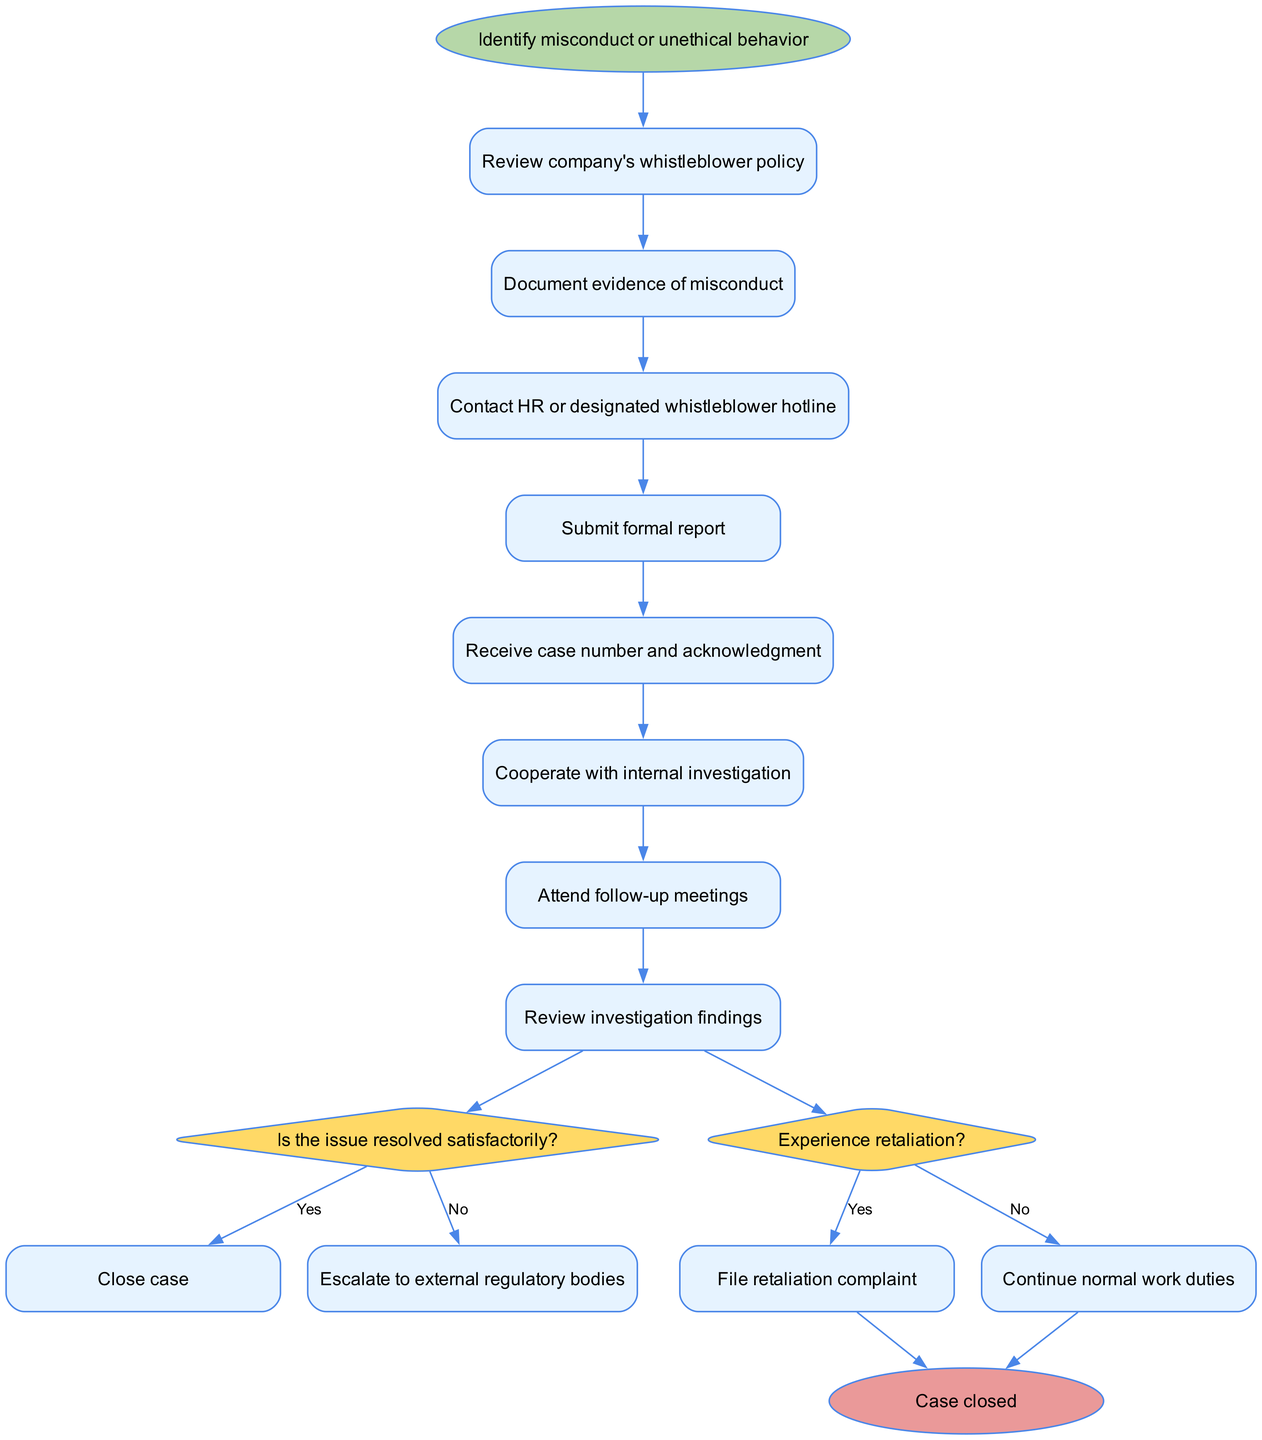What is the starting point of the process? The starting point of the process is indicated as "Identify misconduct or unethical behavior" in the diagram. This is the first node from which all activities flow.
Answer: Identify misconduct or unethical behavior How many activities are in the diagram? By counting the nodes labeled as activities, we find there are eight distinct activities listed before reaching the decision nodes.
Answer: 8 What is the first activity to complete after identifying misconduct? The first activity after the starting point is "Review company's whistleblower policy," which follows directly from the initial identification stage.
Answer: Review company's whistleblower policy What happens if the issue is resolved satisfactorily? If the issue is resolved satisfactorily, the flow indicates we proceed to "Close case," which is the next step following the decision node for satisfactory resolution.
Answer: Close case What is the next step after submitting a formal report? After submitting a formal report, the next step indicated is receiving a case number and acknowledgment, creating a clear flow of activities leading from one to another.
Answer: Receive case number and acknowledgment What are the two potential outcomes after reviewing the investigation findings? The two potential outcomes are labeled under the decision points, which are "Close case" if resolved satisfactorily and "Escalate to external regulatory bodies" if not resolved satisfactorily.
Answer: Close case or Escalate to external regulatory bodies What must you do if you experience retaliation? If retaliation is experienced, the diagram indicates the next action is to "File retaliation complaint," showing a clear response to such an instance.
Answer: File retaliation complaint How many decision nodes are present in the flow? There are two decision nodes present in the diagram, each corresponding to a question about the resolution and retaliation, allowing for branching paths from the investigation findings stage.
Answer: 2 What is the final step in the process? The final step in the process is labeled as "Case closed," indicating that the flow concludes upon resolution and closing of the case as per the diagram's structure.
Answer: Case closed 